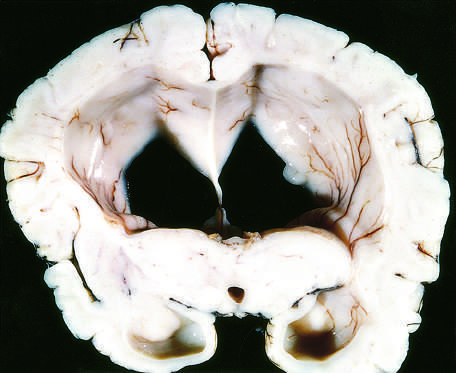re the surfaces of the gyri flattened as a result of compression of the expanding brain by the dura mater and inner surface of the skull?
Answer the question using a single word or phrase. Yes 